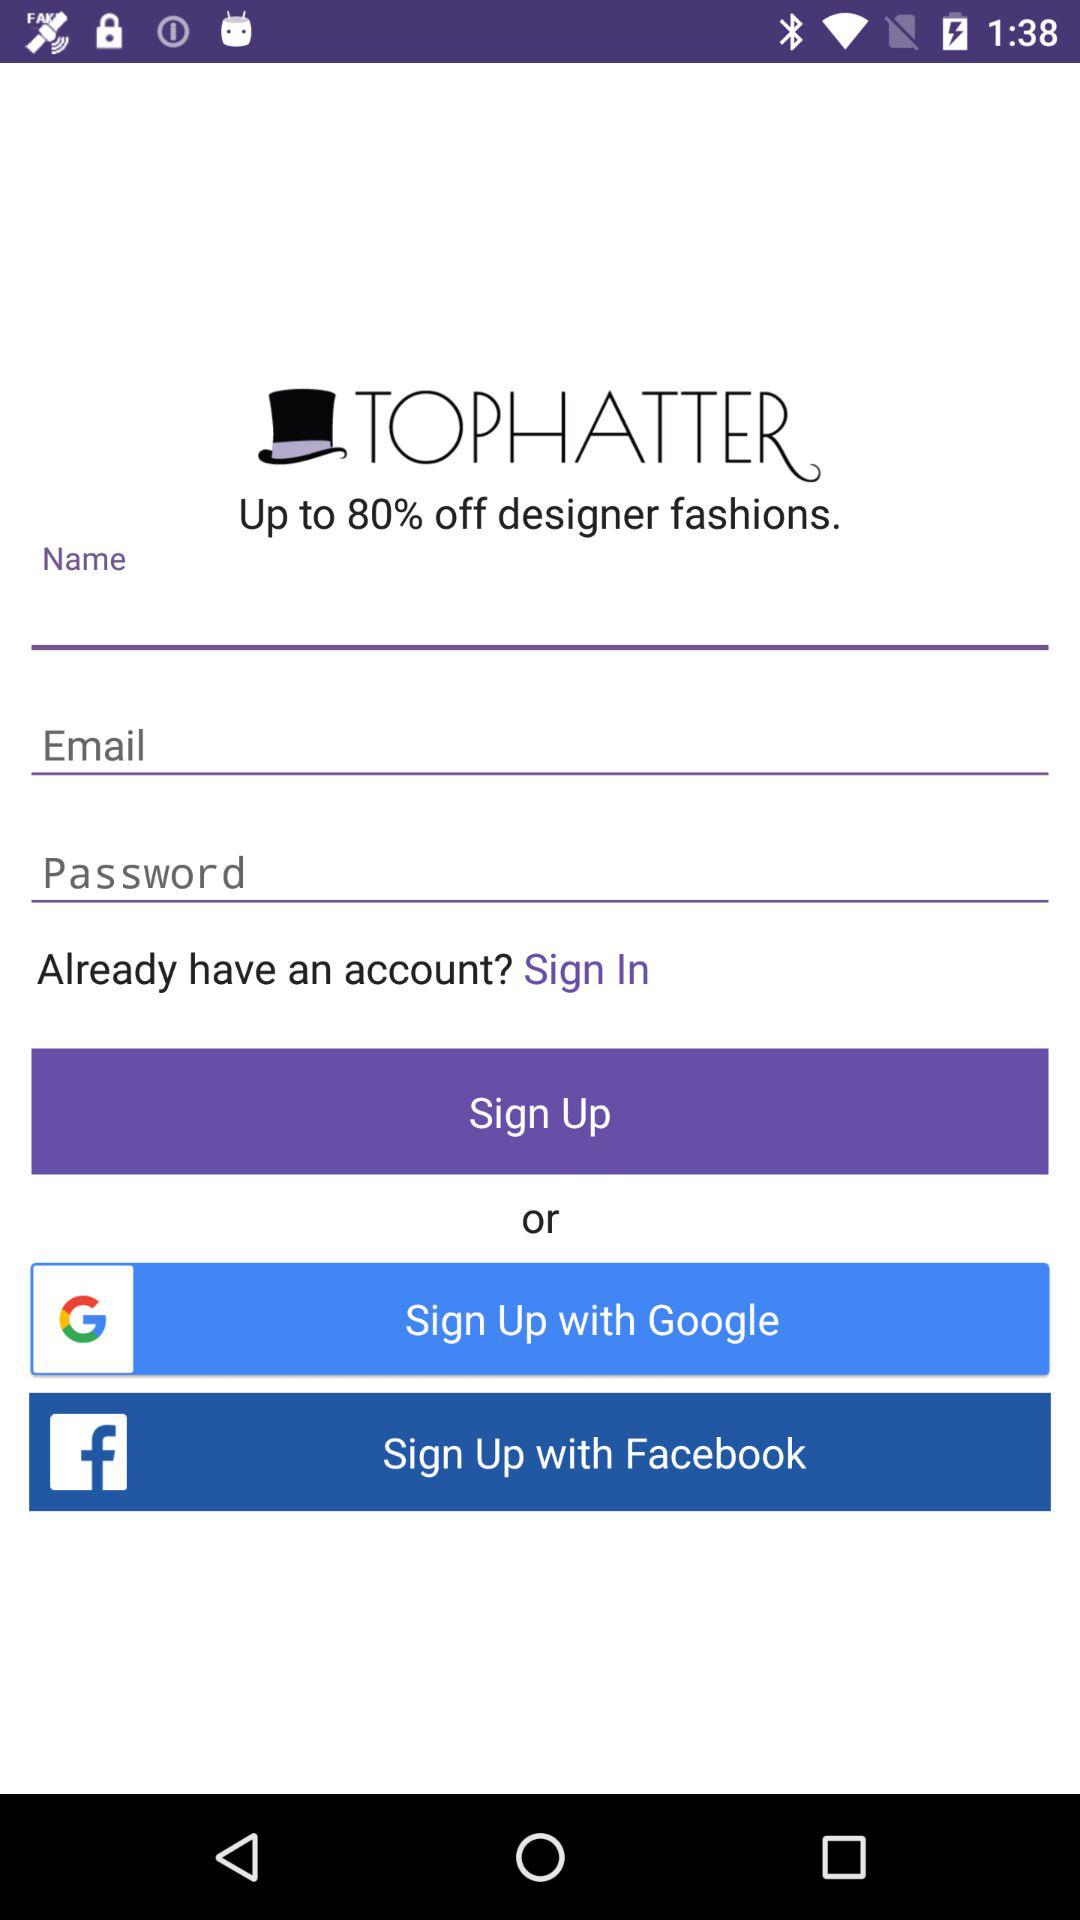How many sign up options are there?
Answer the question using a single word or phrase. 3 